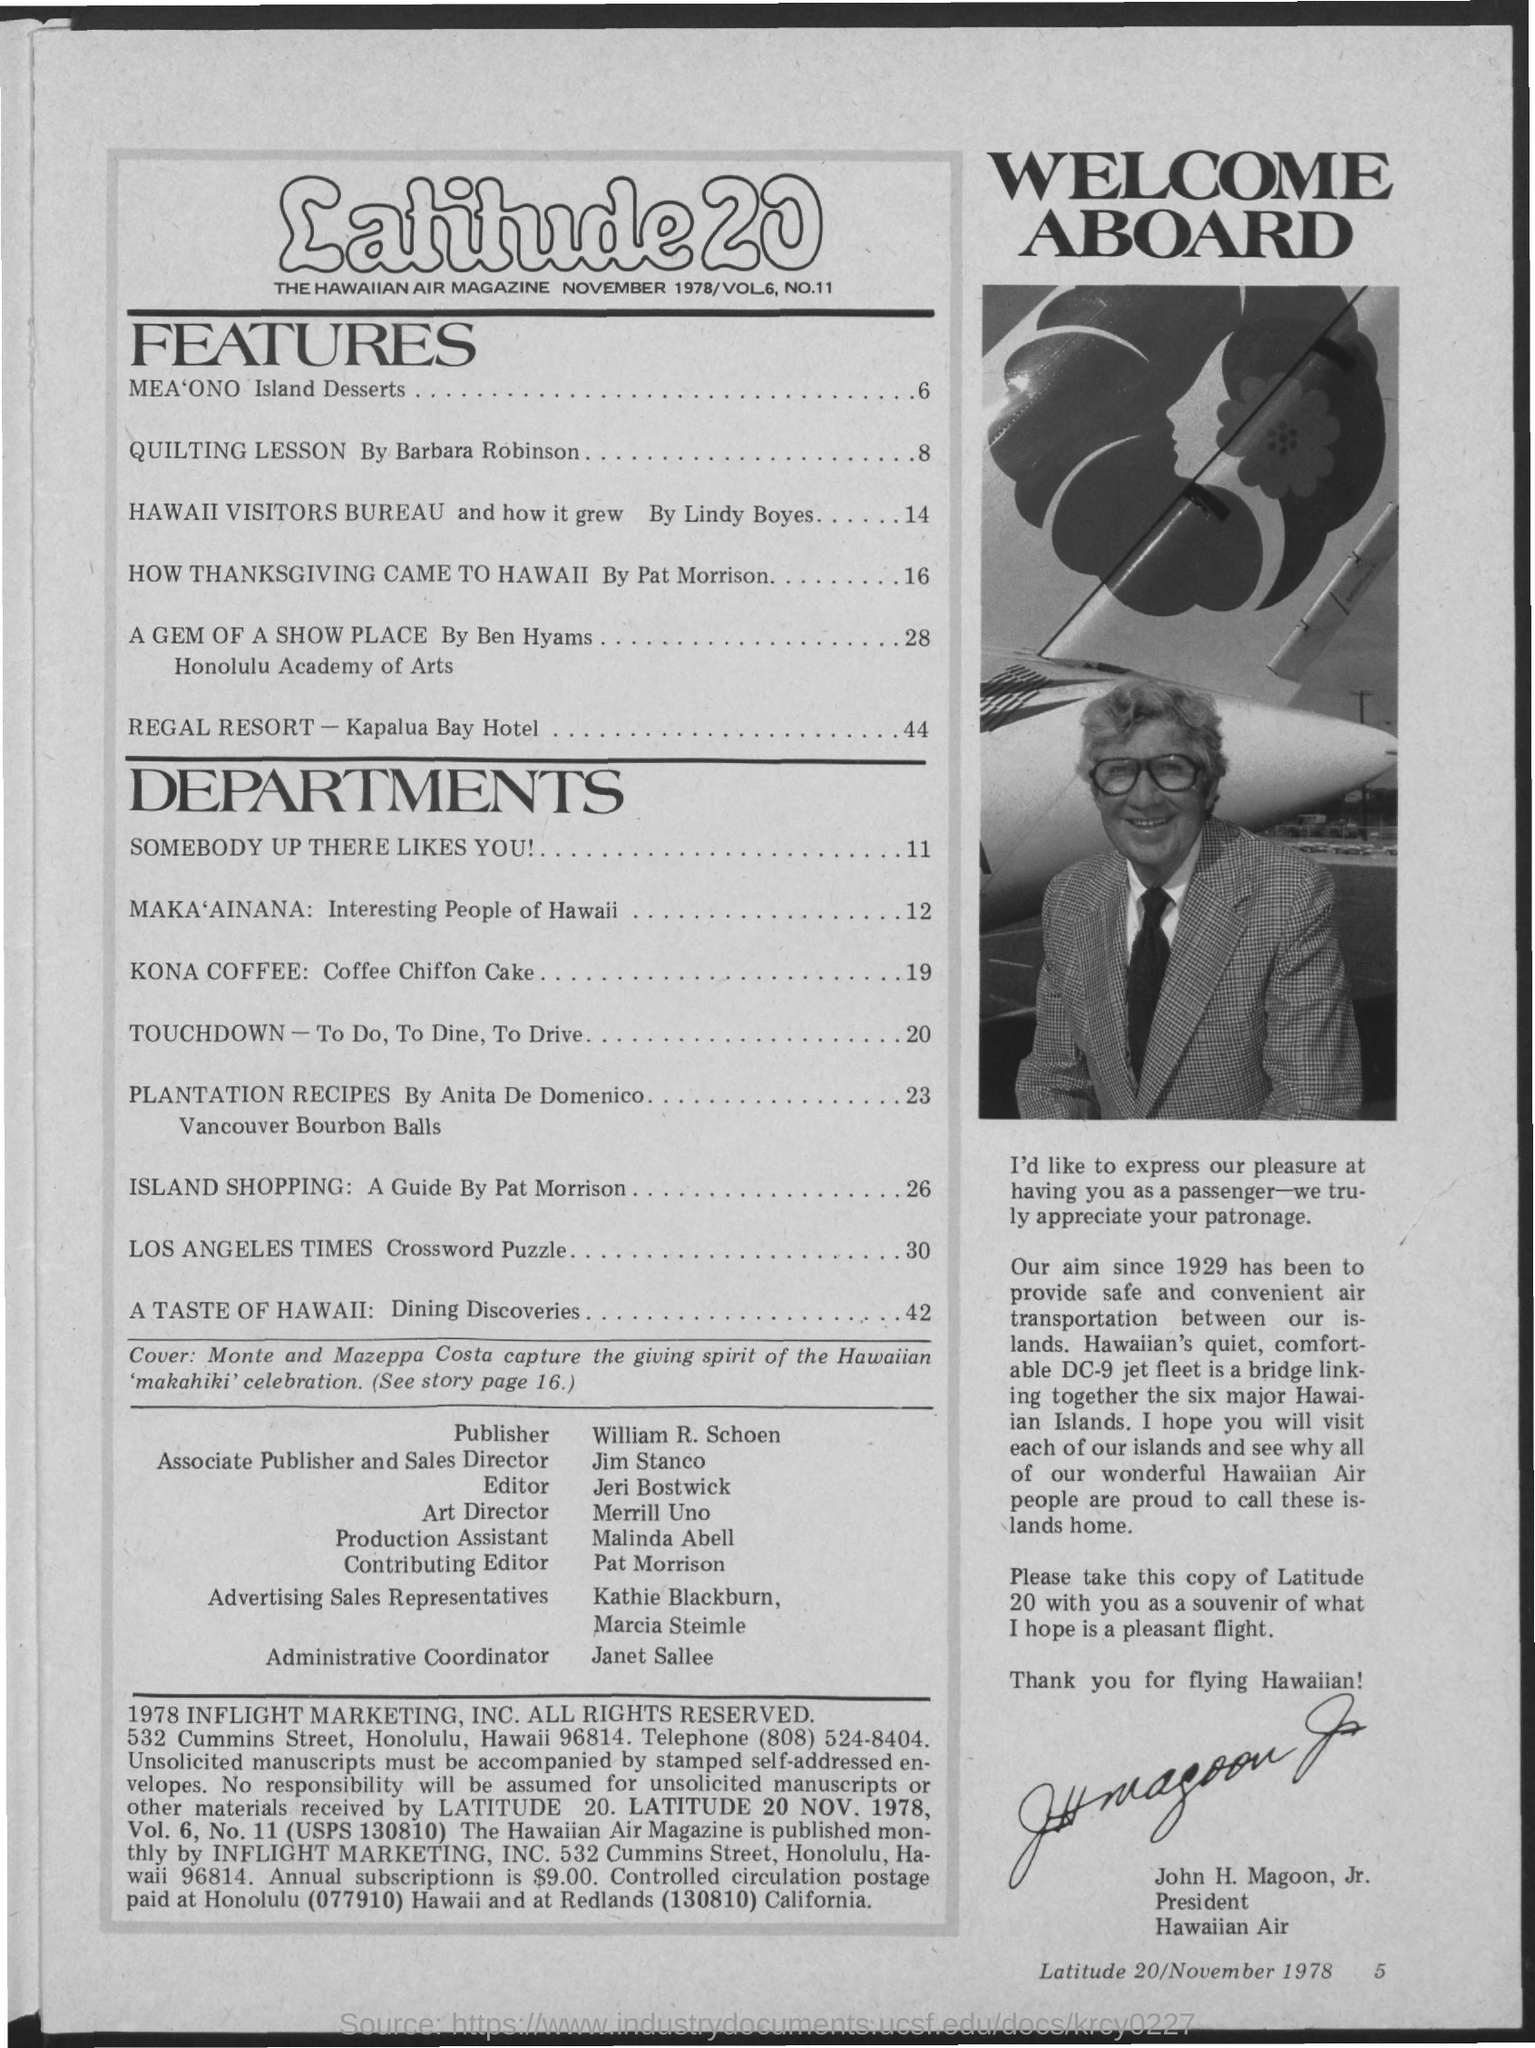What is the name of the air magazine?
Give a very brief answer. Latitude 20. Who wrote QUILTING LESSON?
Provide a succinct answer. Barbara Robinson. What is the page number of A GEM OF A SHOW PLACE?
Ensure brevity in your answer.  28. Who is the Publisher of the magazine?
Offer a terse response. William. Who is the Administrative Coordinator?
Make the answer very short. Janet Sallee. 